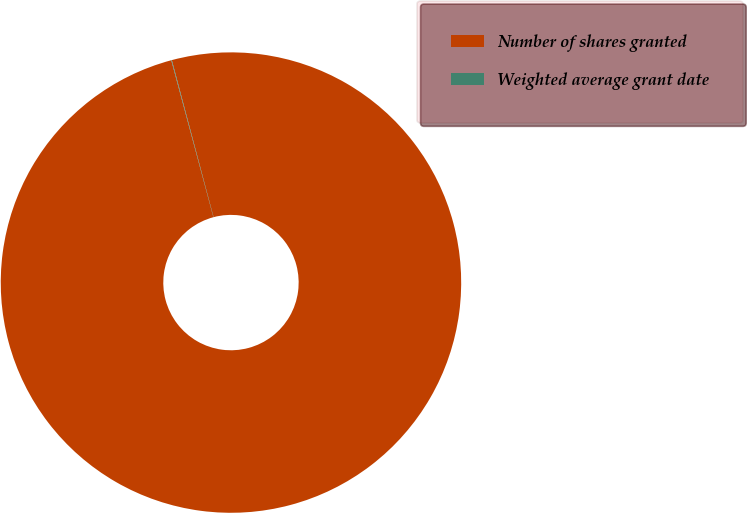Convert chart to OTSL. <chart><loc_0><loc_0><loc_500><loc_500><pie_chart><fcel>Number of shares granted<fcel>Weighted average grant date<nl><fcel>99.96%<fcel>0.04%<nl></chart> 